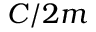Convert formula to latex. <formula><loc_0><loc_0><loc_500><loc_500>C / 2 m</formula> 